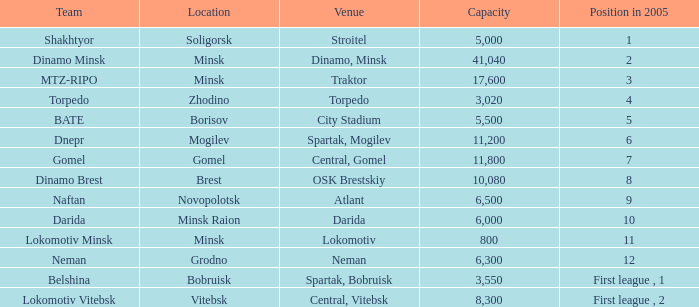Can you inform me of the location that held the rank in 2005 of 8? OSK Brestskiy. 